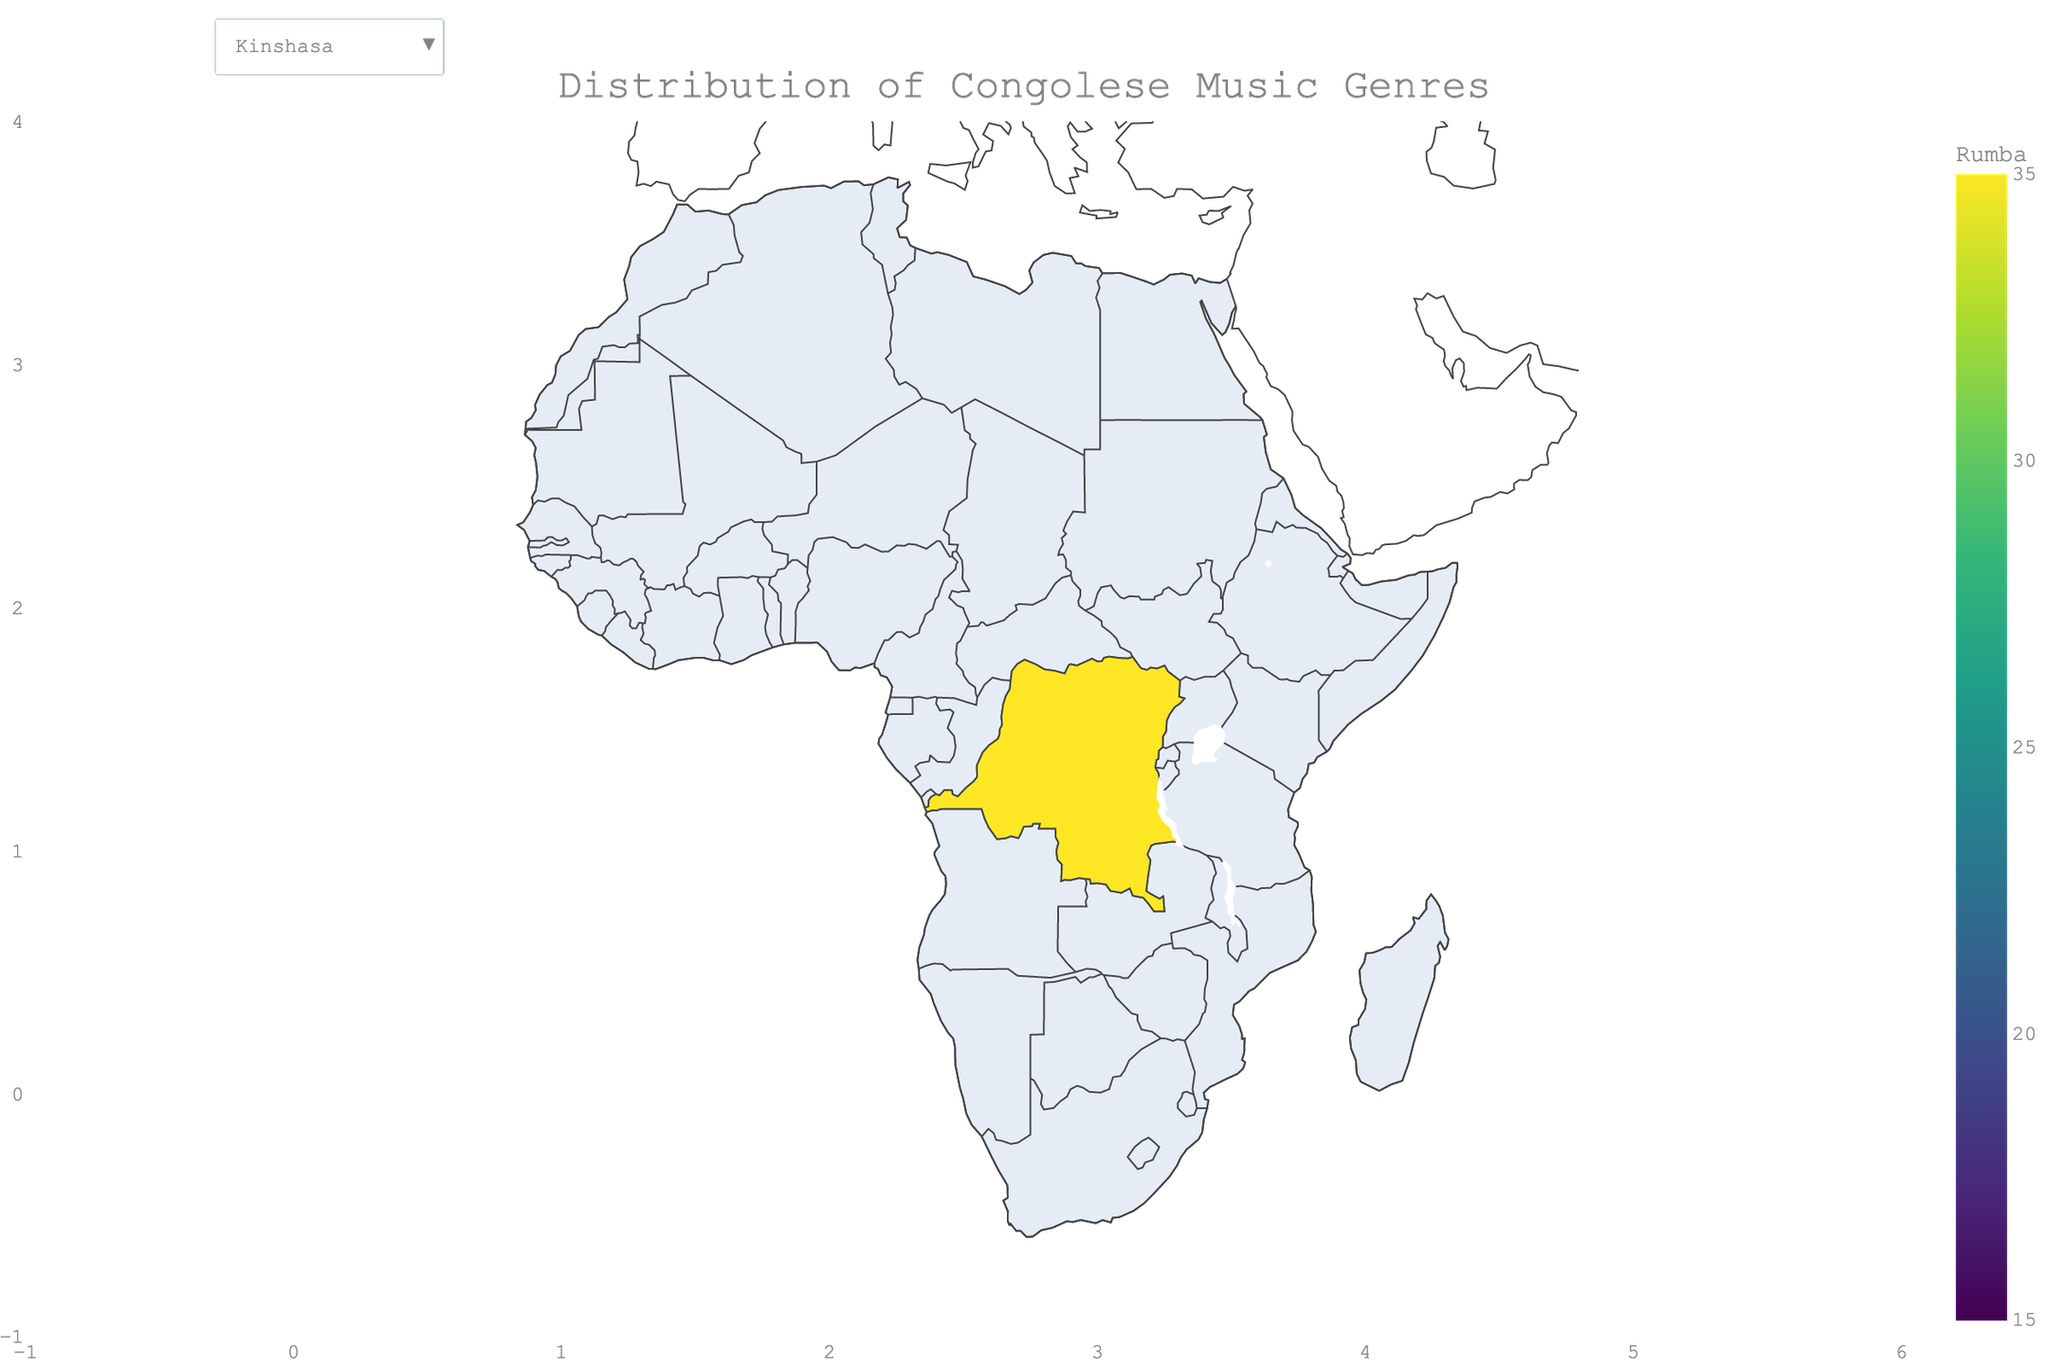What percentage of the music genre distribution for Rumba is in Kinshasa? The figure illustrates the distribution of Congolese music genres across provinces, and the hover information for Kinshasa can be checked directly to see the Rumba percentage.
Answer: 35% Which province has the highest percentage of Folklore? The hover information on the choropleth map shows percentages for each genre. Comparing the percentages for Folklore, Équateur has the highest at 35%.
Answer: Équateur What is the average percentage of Ndombolo across all provinces? Sum the percentages for Ndombolo across all provinces and divide by the number of provinces. (20+15+20+25+20+25+15+15+20+15+20+25+20)/13 = 20%
Answer: 20% Which province has a higher percentage of Gospel music, Nord-Kivu or Kasaï-Central? By comparing the Gospel percentages from the figure, both Nord-Kivu and Kasaï-Central have 10%.
Answer: Both are equal How does the percentage of Soukous in Kinshasa compare to that in Kongo Central? The figure shows the percentage of Soukous in Kinshasa as 30% and in Kongo Central 35%. Kongo Central has a higher percentage.
Answer: Kongo Central In which provinces is Ndombolo the highest and what is the percentage? Examining the hover data, Ndombolo's highest percentage of 25% is in Mai-Ndombe, Mongala, and Lualaba.
Answer: Mai-Ndombe, Mongala, Lualaba at 25% What's the title of the figure? The figure title is explicitly mentioned as "Distribution of Congolese Music Genres".
Answer: Distribution of Congolese Music Genres If you sum the percentages of Rumba in Kinshasa and Kasaï, what would be the result? Adding the Rumba percentages from the figure, Kinshasa (35%) and Kasaï (30%), results in 35 + 30 = 65%.
Answer: 65% Which province has the most balanced distribution of music genres? Balance can be assessed by observing provinces with the most even distribution across genres; Kwilu shows 20-25% across all genres.
Answer: Kwilu How many provinces have a Rumba percentage of 25% or higher? The table shows that Kinshasa, Kongo Central, Nord-Kivu, Kasaï, Kasaï-Central, and Haut-Katanga each have a Rumba percentage of 25% or higher, totaling 6 provinces.
Answer: 6 